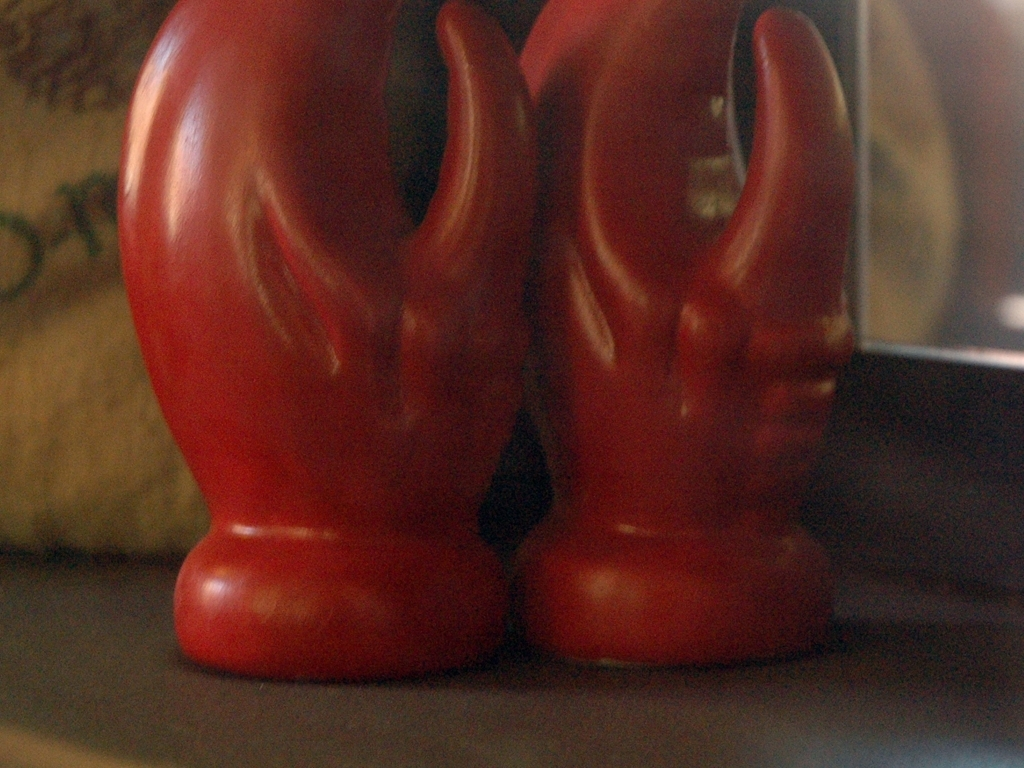How might the lighting conditions have affected the quality of this image? The soft and diffuse lighting in the photo suggests that it may have been taken in low-light conditions or with a light source that doesn't provide sufficient brightness, contributing to the lack of sharpness and potentially causing the camera's sensor to struggle with capturing a clear image. 